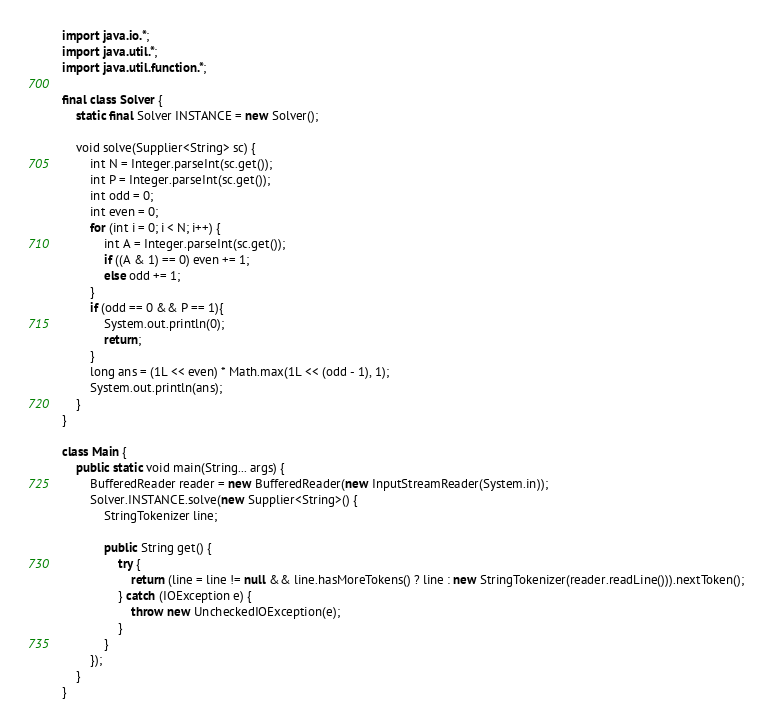<code> <loc_0><loc_0><loc_500><loc_500><_Java_>import java.io.*;
import java.util.*;
import java.util.function.*;

final class Solver {
	static final Solver INSTANCE = new Solver();

	void solve(Supplier<String> sc) {
		int N = Integer.parseInt(sc.get());
		int P = Integer.parseInt(sc.get());
		int odd = 0;
		int even = 0;
		for (int i = 0; i < N; i++) {
			int A = Integer.parseInt(sc.get());
			if ((A & 1) == 0) even += 1;
			else odd += 1;
		}
		if (odd == 0 && P == 1){
			System.out.println(0);
			return;
		}
		long ans = (1L << even) * Math.max(1L << (odd - 1), 1);
		System.out.println(ans);
	}
}

class Main {
	public static void main(String... args) {
		BufferedReader reader = new BufferedReader(new InputStreamReader(System.in));
		Solver.INSTANCE.solve(new Supplier<String>() {
			StringTokenizer line;

			public String get() {
				try {
					return (line = line != null && line.hasMoreTokens() ? line : new StringTokenizer(reader.readLine())).nextToken();
				} catch (IOException e) {
					throw new UncheckedIOException(e);
				}
			}
		});
	}
}</code> 